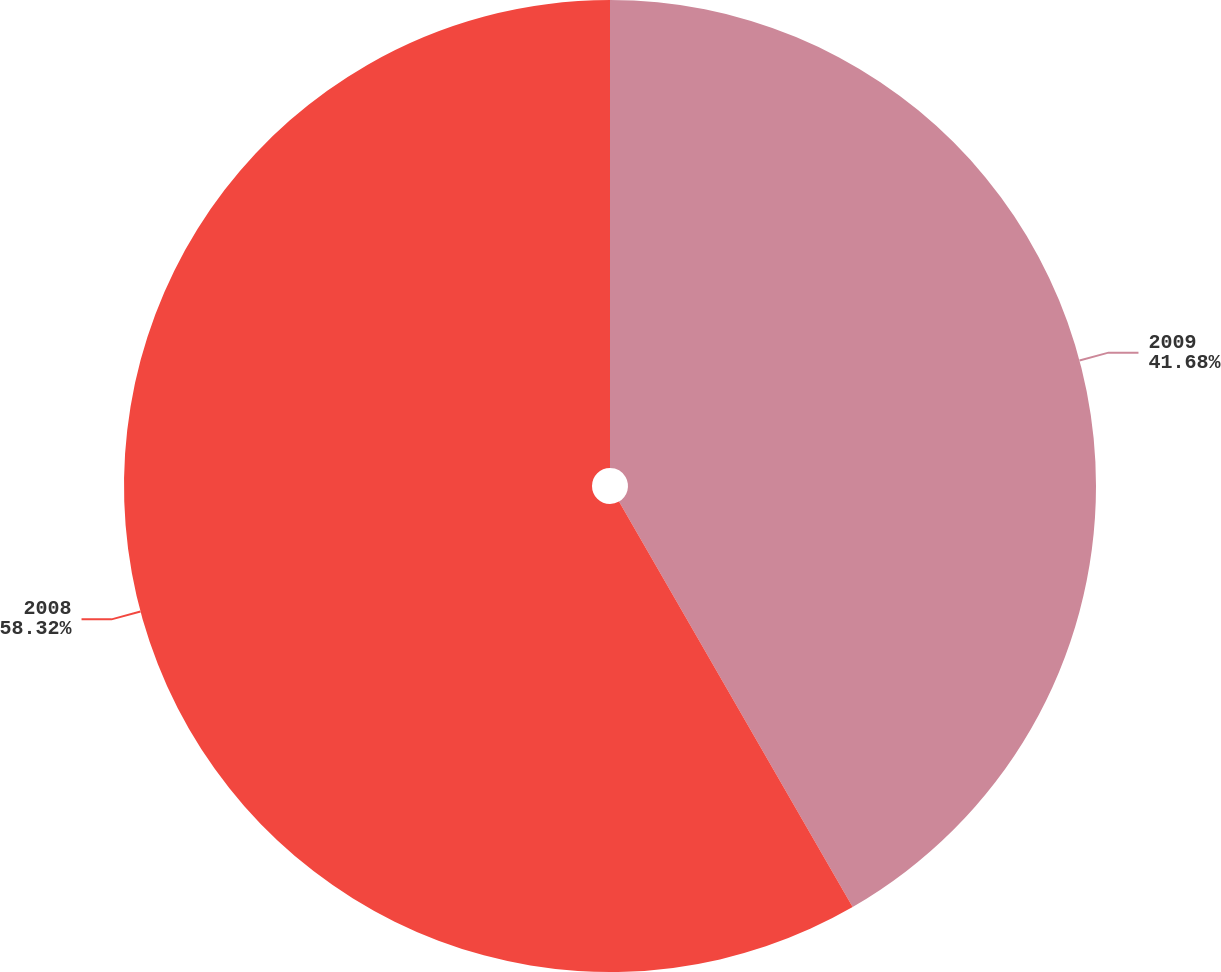<chart> <loc_0><loc_0><loc_500><loc_500><pie_chart><fcel>2009<fcel>2008<nl><fcel>41.68%<fcel>58.32%<nl></chart> 